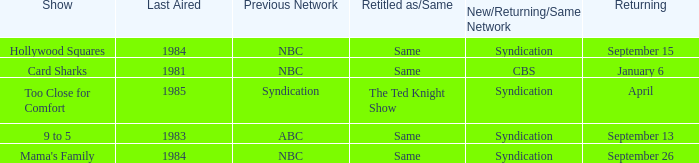When was the show 9 to 5 returning? September 13. 